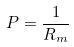Convert formula to latex. <formula><loc_0><loc_0><loc_500><loc_500>P = \frac { 1 } { R _ { m } }</formula> 